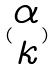<formula> <loc_0><loc_0><loc_500><loc_500>( \begin{matrix} \alpha \\ k \end{matrix} )</formula> 